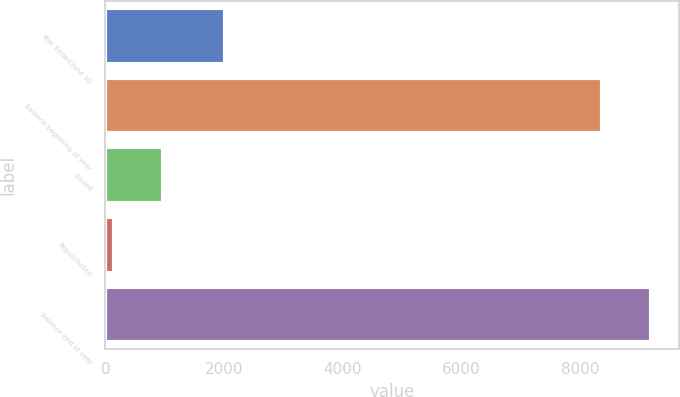Convert chart. <chart><loc_0><loc_0><loc_500><loc_500><bar_chart><fcel>Year Ended June 30<fcel>Balance beginning of year<fcel>Issued<fcel>Repurchased<fcel>Balance end of year<nl><fcel>2012<fcel>8376<fcel>965.9<fcel>142<fcel>9199.9<nl></chart> 